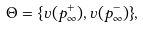Convert formula to latex. <formula><loc_0><loc_0><loc_500><loc_500>\Theta = \{ \upsilon ( p _ { \infty } ^ { + } ) , \upsilon ( p _ { \infty } ^ { - } ) \} ,</formula> 